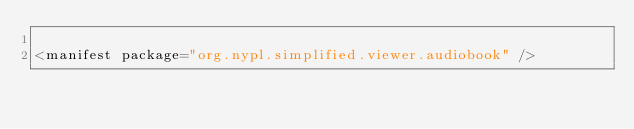Convert code to text. <code><loc_0><loc_0><loc_500><loc_500><_XML_>
<manifest package="org.nypl.simplified.viewer.audiobook" />
</code> 